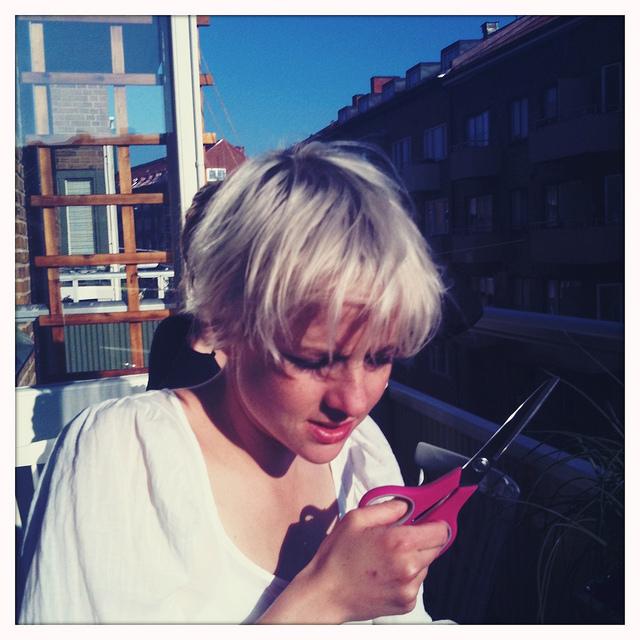What is this person holding?
Short answer required. Scissors. Are the scissors open?
Concise answer only. No. Is the person in the forest?
Concise answer only. No. 